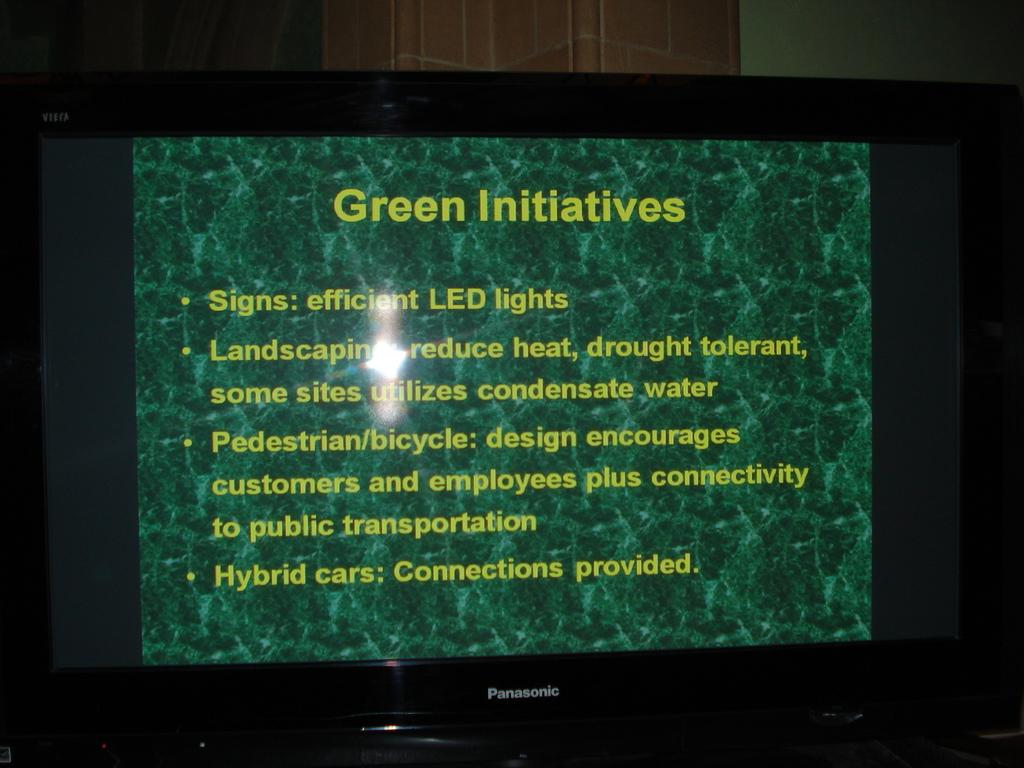<image>
Share a concise interpretation of the image provided. A slide is titled Green Initiatives and has bulletted points. 